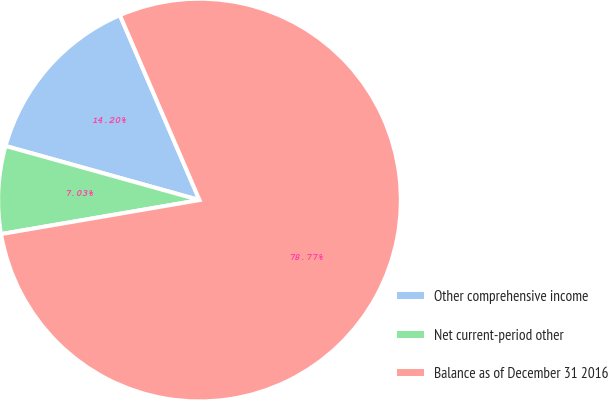Convert chart. <chart><loc_0><loc_0><loc_500><loc_500><pie_chart><fcel>Other comprehensive income<fcel>Net current-period other<fcel>Balance as of December 31 2016<nl><fcel>14.2%<fcel>7.03%<fcel>78.77%<nl></chart> 